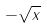Convert formula to latex. <formula><loc_0><loc_0><loc_500><loc_500>- \sqrt { x }</formula> 